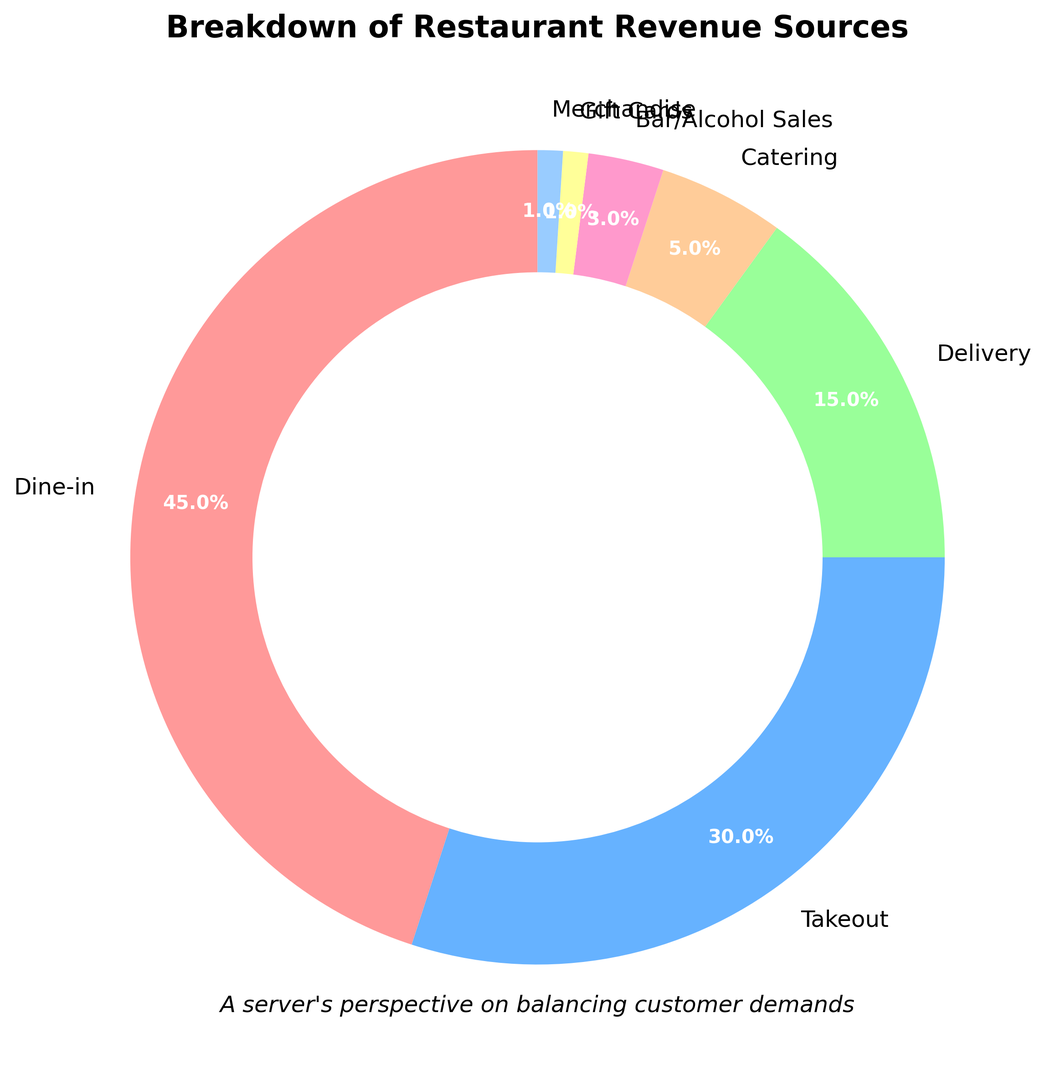What percentage of revenue comes from dine-in and takeout combined? Add the percentages for dine-in (45%) and takeout (30%) to find the combined revenue percentage. 45% + 30% = 75%.
Answer: 75% Which revenue source contributes more: delivery or bar/alcohol sales? Compare the percentages of delivery (15%) and bar/alcohol sales (3%). Delivery contributes more.
Answer: Delivery What is the difference in revenue percentage between the highest and lowest sources? Find the highest revenue percentage (dine-in at 45%) and the lowest (gift cards and merchandise at 1% each). Subtract the lowest value from the highest: 45% - 1% = 44%.
Answer: 44% How much more revenue does dine-in generate compared to catering? Compare dine-in (45%) and catering (5%). Subtract the percentage of catering from dine-in: 45% - 5% = 40%.
Answer: 40% Which category takes up a small segment but is visually represented in pink in the chart? Identify the segment color corresponding to small categories. The bar/alcohol sales segment is small and visually represented in pink.
Answer: Bar/Alcohol Sales Is the sum of revenue from delivery, catering, gift cards, and merchandise larger or smaller than dine-in revenue? Add the percentages for delivery (15%), catering (5%), gift cards (1%), and merchandise (1%). Compare the sum to dine-in revenue (45%). The sum is 15% + 5% + 1% + 1% = 22%, which is smaller than 45%.
Answer: Smaller What revenue source comes second after dine-in in terms of revenue percentage? Identify the revenue source with the second-highest percentage after dine-in. Takeout is 30%.
Answer: Takeout Which revenue source has the smallest contribution, and what percentage does it represent? Identify the smallest percentage. Gift cards and merchandise both have the smallest contribution, each at 1%.
Answer: Gift Cards and Merchandise; 1% By how much does takeout revenue exceed delivery revenue? Compare takeout (30%) and delivery (15%) revenue. Subtract delivery revenue from takeout revenue: 30% - 15% = 15%.
Answer: 15% Is the total percentage of non-dine-in sources (takeout, delivery, catering, bar/alcohol sales, gift cards, merchandise) more than 50%? Add the percentages of all non-dine-in sources: 30% (takeout) + 15% (delivery) + 5% (catering) + 3% (bar/alcohol sales) + 1% (gift cards) + 1% (merchandise). The sum is 55%, which is more than 50%.
Answer: Yes 